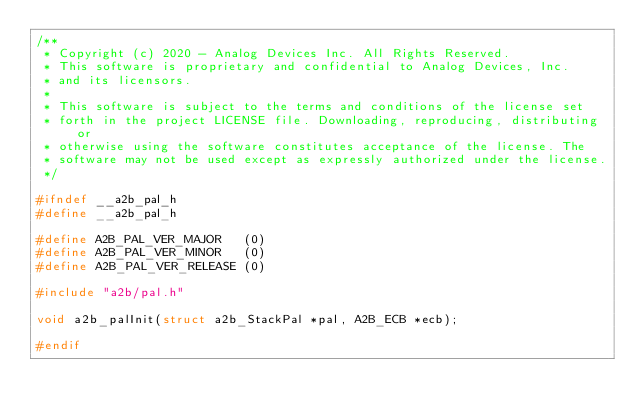Convert code to text. <code><loc_0><loc_0><loc_500><loc_500><_C_>/**
 * Copyright (c) 2020 - Analog Devices Inc. All Rights Reserved.
 * This software is proprietary and confidential to Analog Devices, Inc.
 * and its licensors.
 *
 * This software is subject to the terms and conditions of the license set
 * forth in the project LICENSE file. Downloading, reproducing, distributing or
 * otherwise using the software constitutes acceptance of the license. The
 * software may not be used except as expressly authorized under the license.
 */

#ifndef __a2b_pal_h
#define __a2b_pal_h

#define A2B_PAL_VER_MAJOR   (0)
#define A2B_PAL_VER_MINOR   (0)
#define A2B_PAL_VER_RELEASE (0)

#include "a2b/pal.h"

void a2b_palInit(struct a2b_StackPal *pal, A2B_ECB *ecb);

#endif
</code> 